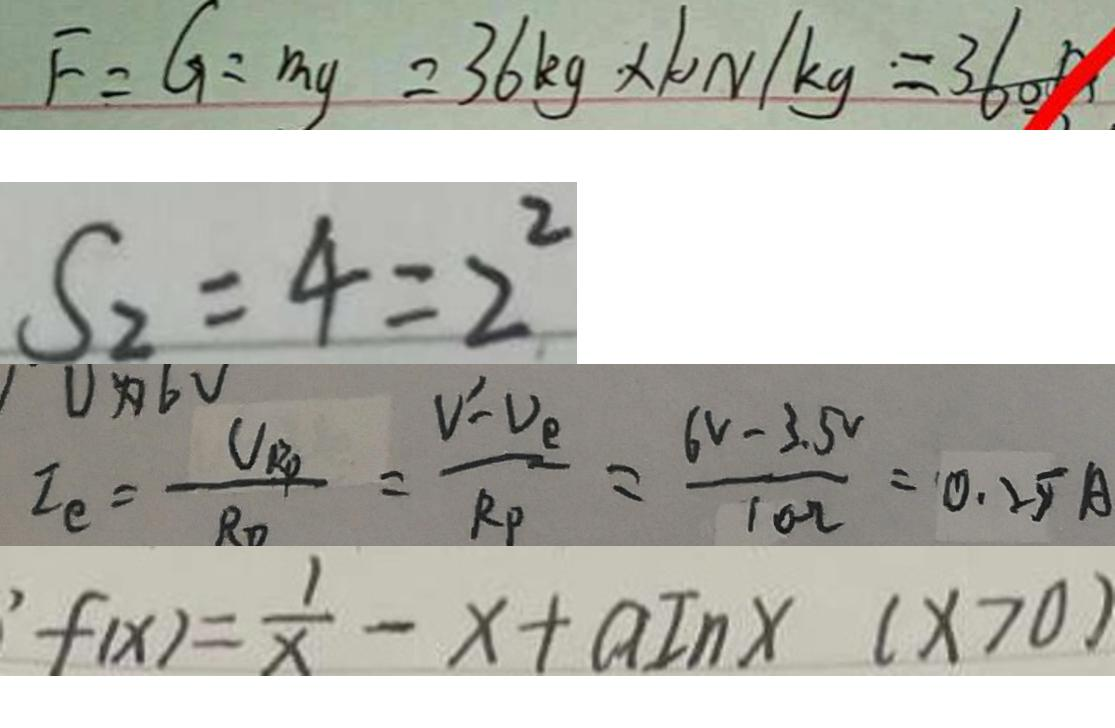<formula> <loc_0><loc_0><loc_500><loc_500>F = G = m g = 3 6 k g \times 1 0 N / k g = 3 6 0 0 
 S _ { 2 } = 4 = 2 ^ { 2 } 
 I _ { e } = \frac { U _ { R P } } { R _ { 0 } } = \frac { V ^ { 1 } - V _ { e } } { R _ { P } } = \frac { ( 6 V - 3 . 5 ^ { V } } { 1 0 \Omega } = 0 . 2 5 A 
 \prime f ( x ) = \frac { 1 } { x } - x + a I n x ( x > 0 )</formula> 